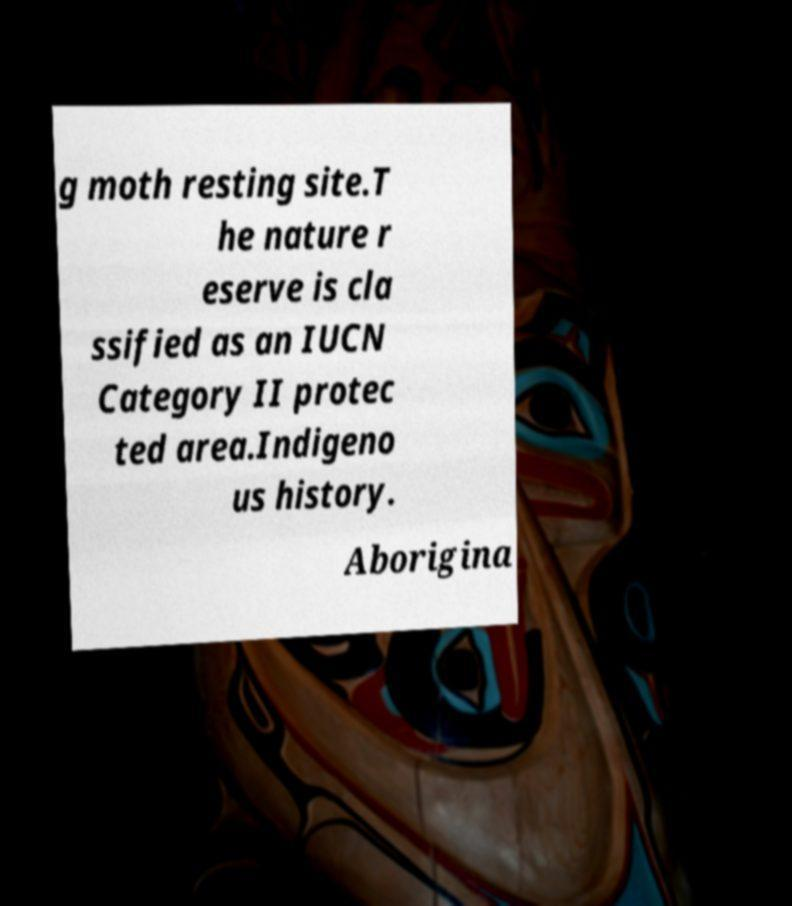There's text embedded in this image that I need extracted. Can you transcribe it verbatim? g moth resting site.T he nature r eserve is cla ssified as an IUCN Category II protec ted area.Indigeno us history. Aborigina 